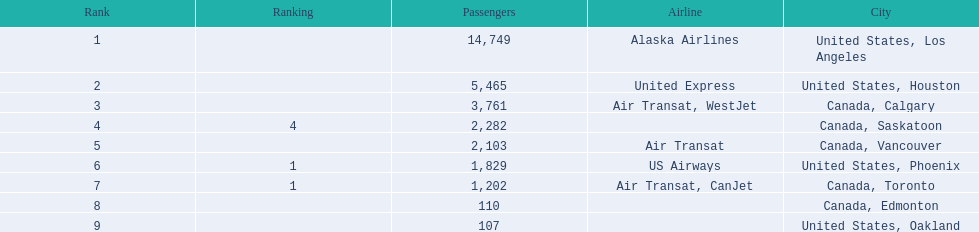Where are the destinations of the airport? United States, Los Angeles, United States, Houston, Canada, Calgary, Canada, Saskatoon, Canada, Vancouver, United States, Phoenix, Canada, Toronto, Canada, Edmonton, United States, Oakland. What is the number of passengers to phoenix? 1,829. 